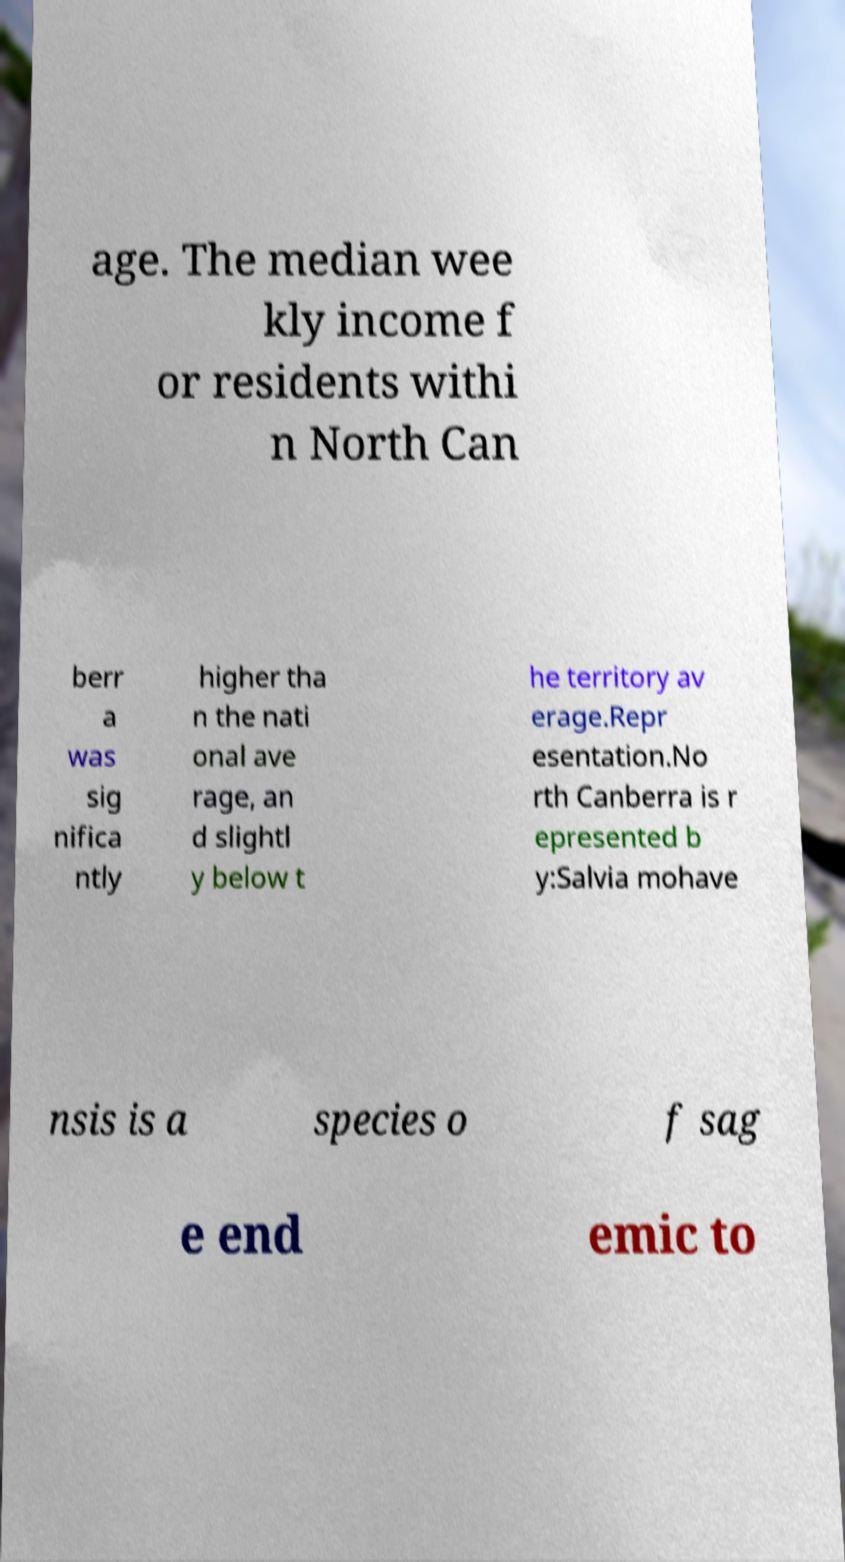I need the written content from this picture converted into text. Can you do that? age. The median wee kly income f or residents withi n North Can berr a was sig nifica ntly higher tha n the nati onal ave rage, an d slightl y below t he territory av erage.Repr esentation.No rth Canberra is r epresented b y:Salvia mohave nsis is a species o f sag e end emic to 